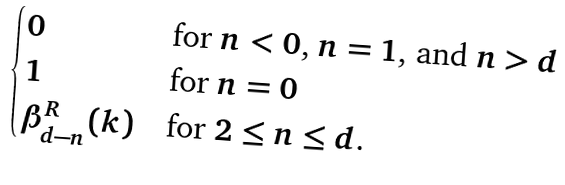Convert formula to latex. <formula><loc_0><loc_0><loc_500><loc_500>\begin{cases} 0 & \text {for $n<0$, $n=1$, and $n>d$} \\ 1 & \text {for $n=0$} \\ \beta _ { d - n } ^ { R } ( k ) & \text {for $2 \leq n \leq d$.} \end{cases}</formula> 